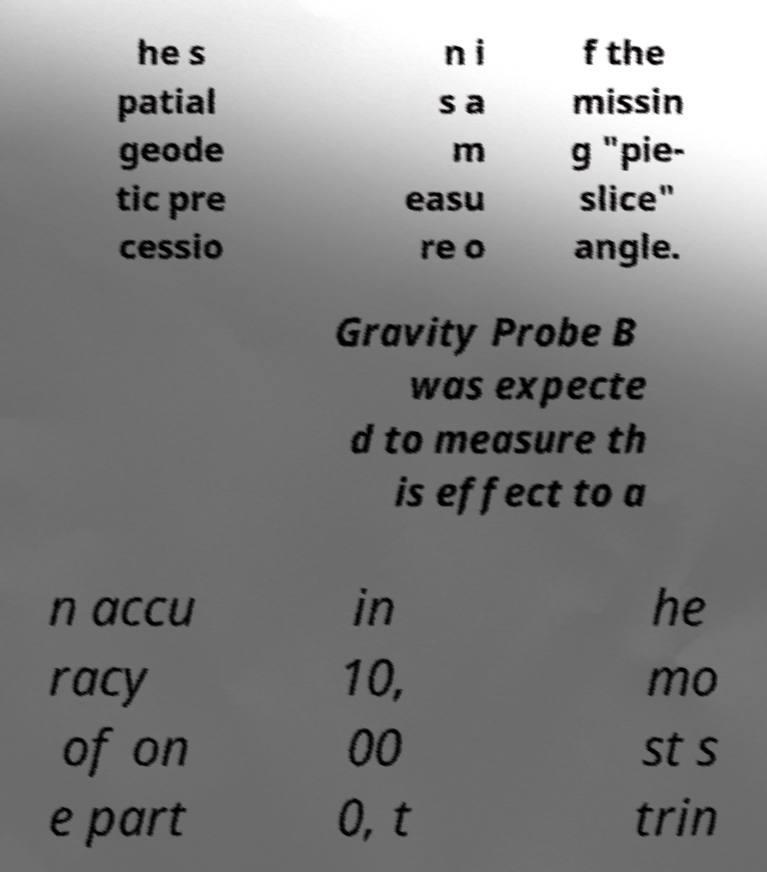What messages or text are displayed in this image? I need them in a readable, typed format. he s patial geode tic pre cessio n i s a m easu re o f the missin g "pie- slice" angle. Gravity Probe B was expecte d to measure th is effect to a n accu racy of on e part in 10, 00 0, t he mo st s trin 